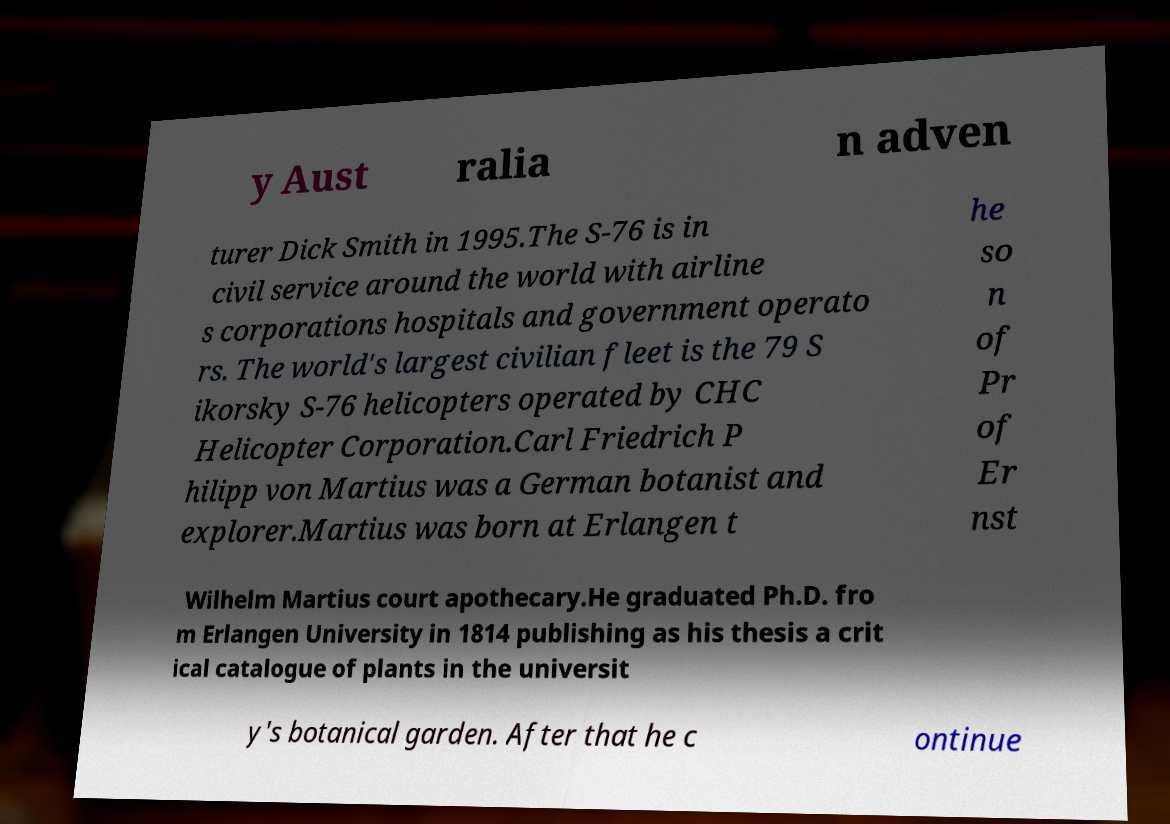For documentation purposes, I need the text within this image transcribed. Could you provide that? y Aust ralia n adven turer Dick Smith in 1995.The S-76 is in civil service around the world with airline s corporations hospitals and government operato rs. The world's largest civilian fleet is the 79 S ikorsky S-76 helicopters operated by CHC Helicopter Corporation.Carl Friedrich P hilipp von Martius was a German botanist and explorer.Martius was born at Erlangen t he so n of Pr of Er nst Wilhelm Martius court apothecary.He graduated Ph.D. fro m Erlangen University in 1814 publishing as his thesis a crit ical catalogue of plants in the universit y's botanical garden. After that he c ontinue 